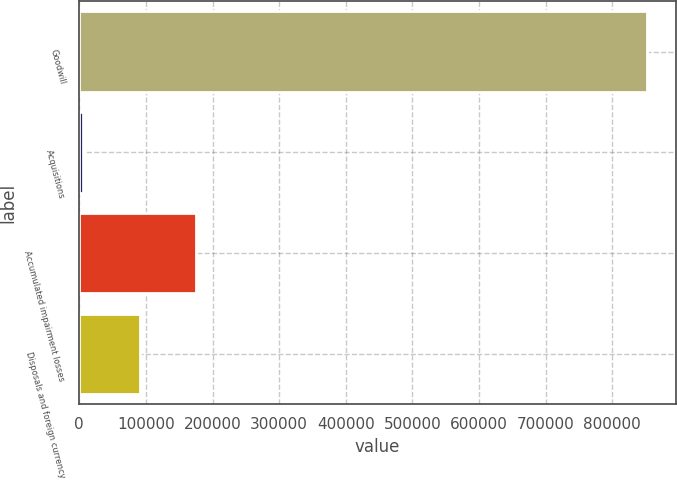<chart> <loc_0><loc_0><loc_500><loc_500><bar_chart><fcel>Goodwill<fcel>Acquisitions<fcel>Accumulated impairment losses<fcel>Disposals and foreign currency<nl><fcel>852418<fcel>6248<fcel>175482<fcel>90865<nl></chart> 